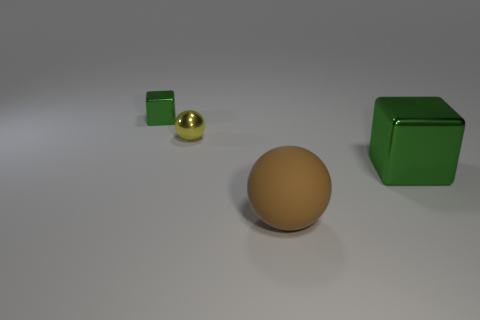Add 1 brown metal balls. How many objects exist? 5 Subtract 0 cyan blocks. How many objects are left? 4 Subtract all brown cylinders. Subtract all small yellow metal objects. How many objects are left? 3 Add 1 tiny green metallic blocks. How many tiny green metallic blocks are left? 2 Add 4 yellow shiny things. How many yellow shiny things exist? 5 